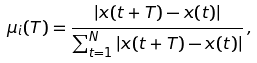<formula> <loc_0><loc_0><loc_500><loc_500>\mu _ { i } ( T ) = \frac { | x ( t + T ) - x ( t ) | } { \sum _ { t = 1 } ^ { N } | x ( t + T ) - x ( t ) | } \, ,</formula> 